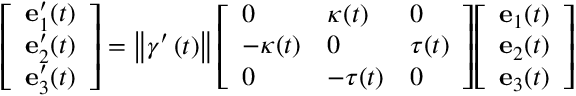<formula> <loc_0><loc_0><loc_500><loc_500>{ \left [ \begin{array} { l } { e _ { 1 } ^ { \prime } ( t ) } \\ { e _ { 2 } ^ { \prime } ( t ) } \\ { e _ { 3 } ^ { \prime } ( t ) } \end{array} \right ] } = \left \| \gamma ^ { \prime } \left ( t \right ) \right \| { \left [ \begin{array} { l l l } { 0 } & { \kappa ( t ) } & { 0 } \\ { - \kappa ( t ) } & { 0 } & { \tau ( t ) } \\ { 0 } & { - \tau ( t ) } & { 0 } \end{array} \right ] } { \left [ \begin{array} { l } { e _ { 1 } ( t ) } \\ { e _ { 2 } ( t ) } \\ { e _ { 3 } ( t ) } \end{array} \right ] }</formula> 